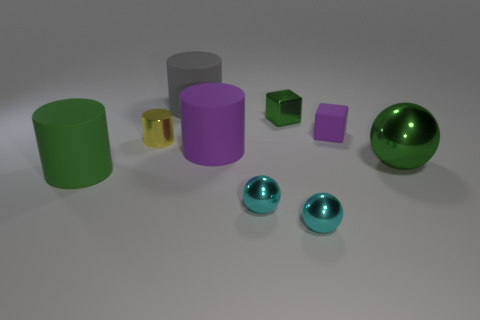Subtract all blue cylinders. Subtract all red spheres. How many cylinders are left? 4 Subtract all blocks. How many objects are left? 7 Subtract all rubber cylinders. Subtract all green metallic cylinders. How many objects are left? 6 Add 7 tiny metal cubes. How many tiny metal cubes are left? 8 Add 1 large matte balls. How many large matte balls exist? 1 Subtract 1 gray cylinders. How many objects are left? 8 